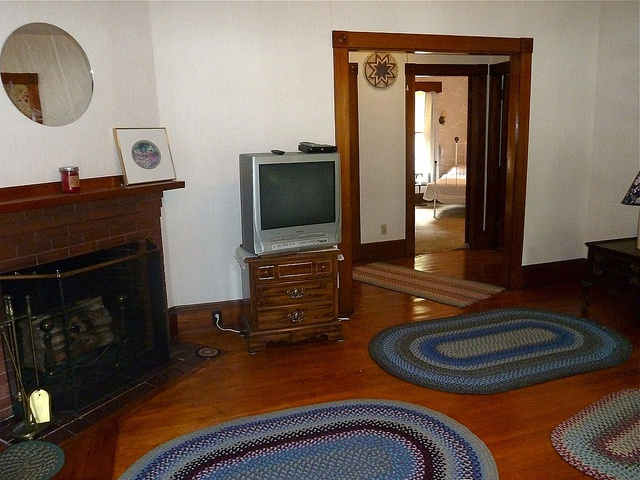Describe the objects in this image and their specific colors. I can see tv in lightgray, black, gray, and darkgray tones, bed in lightgray, gray, tan, and ivory tones, remote in lightgray, gray, black, and darkgray tones, and remote in lightgray, black, and gray tones in this image. 